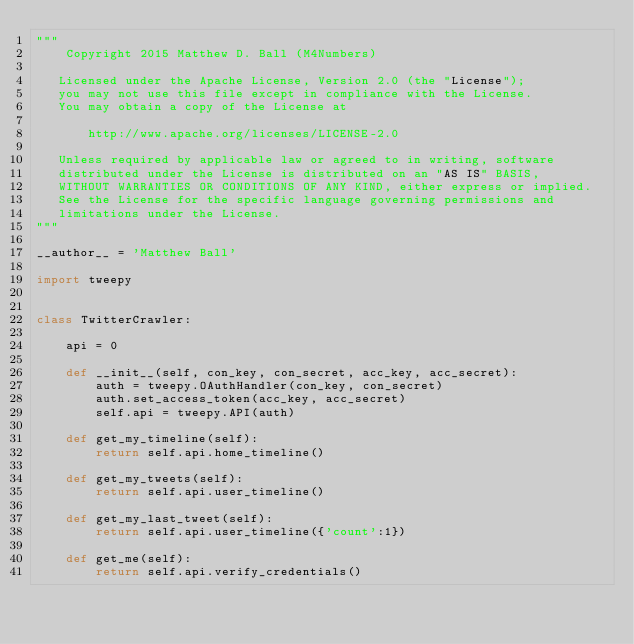Convert code to text. <code><loc_0><loc_0><loc_500><loc_500><_Python_>"""
    Copyright 2015 Matthew D. Ball (M4Numbers)

   Licensed under the Apache License, Version 2.0 (the "License");
   you may not use this file except in compliance with the License.
   You may obtain a copy of the License at

       http://www.apache.org/licenses/LICENSE-2.0

   Unless required by applicable law or agreed to in writing, software
   distributed under the License is distributed on an "AS IS" BASIS,
   WITHOUT WARRANTIES OR CONDITIONS OF ANY KIND, either express or implied.
   See the License for the specific language governing permissions and
   limitations under the License.
"""

__author__ = 'Matthew Ball'

import tweepy


class TwitterCrawler:

    api = 0

    def __init__(self, con_key, con_secret, acc_key, acc_secret):
        auth = tweepy.OAuthHandler(con_key, con_secret)
        auth.set_access_token(acc_key, acc_secret)
        self.api = tweepy.API(auth)

    def get_my_timeline(self):
        return self.api.home_timeline()

    def get_my_tweets(self):
        return self.api.user_timeline()

    def get_my_last_tweet(self):
        return self.api.user_timeline({'count':1})

    def get_me(self):
        return self.api.verify_credentials()
</code> 